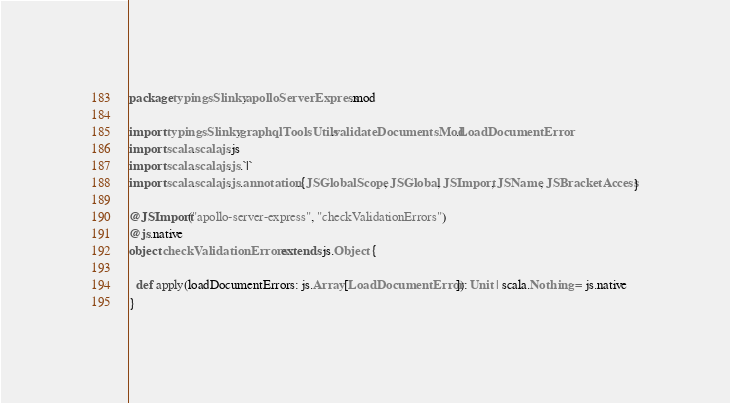<code> <loc_0><loc_0><loc_500><loc_500><_Scala_>package typingsSlinky.apolloServerExpress.mod

import typingsSlinky.graphqlToolsUtils.validateDocumentsMod.LoadDocumentError
import scala.scalajs.js
import scala.scalajs.js.`|`
import scala.scalajs.js.annotation.{JSGlobalScope, JSGlobal, JSImport, JSName, JSBracketAccess}

@JSImport("apollo-server-express", "checkValidationErrors")
@js.native
object checkValidationErrors extends js.Object {
  
  def apply(loadDocumentErrors: js.Array[LoadDocumentError]): Unit | scala.Nothing = js.native
}
</code> 